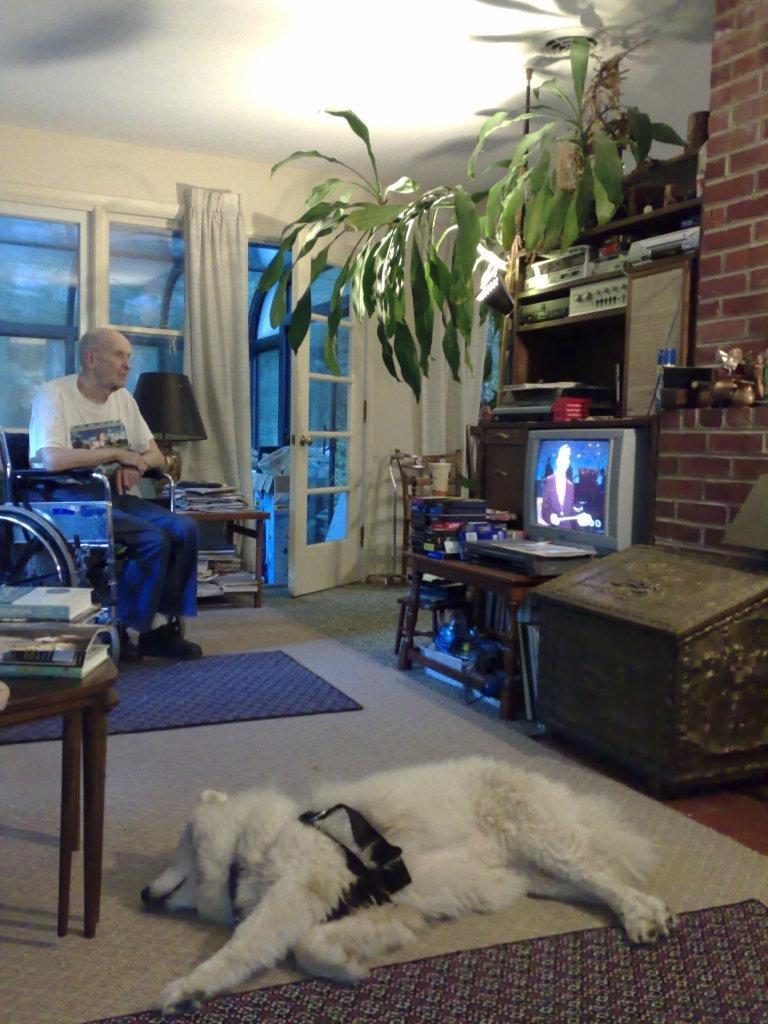In one or two sentences, can you explain what this image depicts? In this picture there is a dog lying on the floor at the bottom side of the image and there are books on the table on the left side of the image and there is an old man who is sitting on the wheel chair on the left side of the image, there is a television, planter, box, and other electronics on the right side of the image, there are books, windows and a lamp in the background area of the image. 